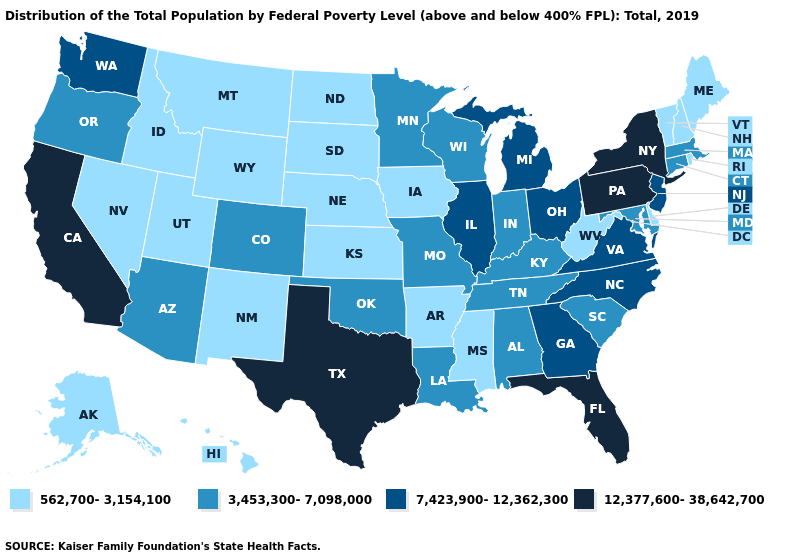Does Delaware have the highest value in the South?
Be succinct. No. Which states have the highest value in the USA?
Quick response, please. California, Florida, New York, Pennsylvania, Texas. What is the lowest value in the USA?
Short answer required. 562,700-3,154,100. Name the states that have a value in the range 3,453,300-7,098,000?
Be succinct. Alabama, Arizona, Colorado, Connecticut, Indiana, Kentucky, Louisiana, Maryland, Massachusetts, Minnesota, Missouri, Oklahoma, Oregon, South Carolina, Tennessee, Wisconsin. Name the states that have a value in the range 3,453,300-7,098,000?
Short answer required. Alabama, Arizona, Colorado, Connecticut, Indiana, Kentucky, Louisiana, Maryland, Massachusetts, Minnesota, Missouri, Oklahoma, Oregon, South Carolina, Tennessee, Wisconsin. Which states have the highest value in the USA?
Give a very brief answer. California, Florida, New York, Pennsylvania, Texas. Which states have the lowest value in the USA?
Quick response, please. Alaska, Arkansas, Delaware, Hawaii, Idaho, Iowa, Kansas, Maine, Mississippi, Montana, Nebraska, Nevada, New Hampshire, New Mexico, North Dakota, Rhode Island, South Dakota, Utah, Vermont, West Virginia, Wyoming. What is the lowest value in the USA?
Keep it brief. 562,700-3,154,100. What is the highest value in the USA?
Write a very short answer. 12,377,600-38,642,700. What is the value of Oregon?
Write a very short answer. 3,453,300-7,098,000. What is the lowest value in states that border Oklahoma?
Quick response, please. 562,700-3,154,100. What is the value of Kentucky?
Keep it brief. 3,453,300-7,098,000. Does North Carolina have the highest value in the USA?
Quick response, please. No. What is the value of Pennsylvania?
Quick response, please. 12,377,600-38,642,700. Name the states that have a value in the range 3,453,300-7,098,000?
Answer briefly. Alabama, Arizona, Colorado, Connecticut, Indiana, Kentucky, Louisiana, Maryland, Massachusetts, Minnesota, Missouri, Oklahoma, Oregon, South Carolina, Tennessee, Wisconsin. 